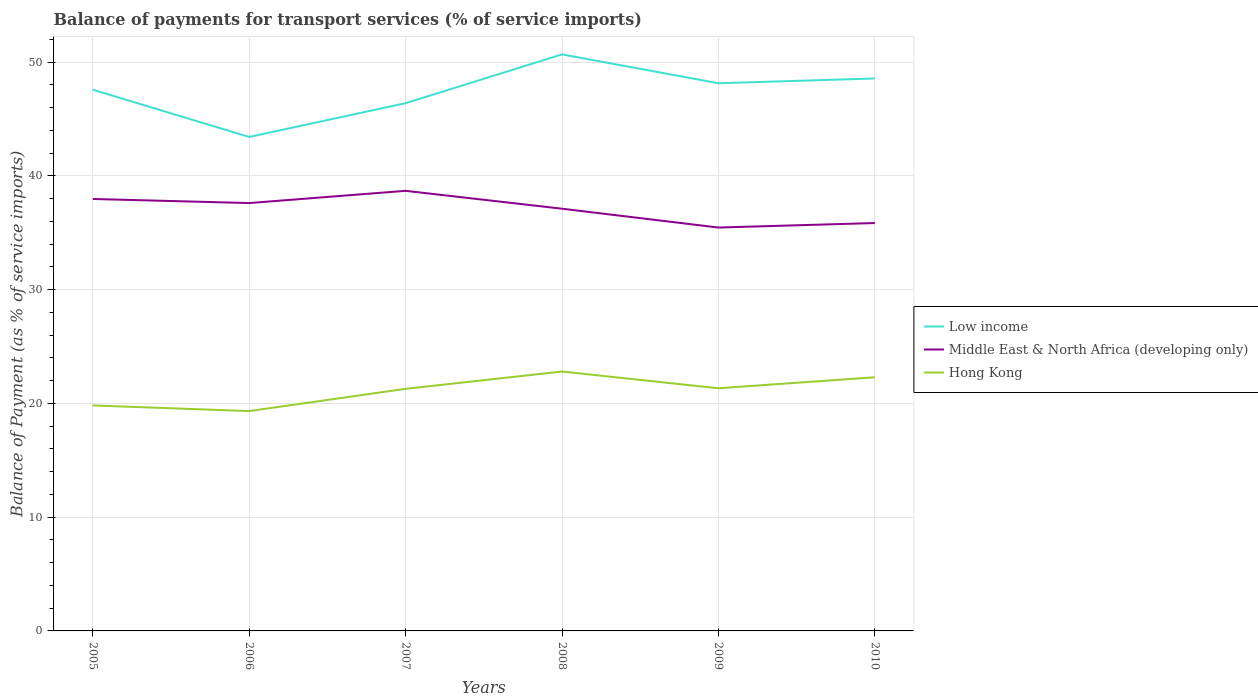How many different coloured lines are there?
Offer a very short reply. 3. Does the line corresponding to Middle East & North Africa (developing only) intersect with the line corresponding to Hong Kong?
Keep it short and to the point. No. Across all years, what is the maximum balance of payments for transport services in Low income?
Make the answer very short. 43.42. What is the total balance of payments for transport services in Hong Kong in the graph?
Offer a very short reply. -2.48. What is the difference between the highest and the second highest balance of payments for transport services in Middle East & North Africa (developing only)?
Offer a very short reply. 3.23. Is the balance of payments for transport services in Low income strictly greater than the balance of payments for transport services in Middle East & North Africa (developing only) over the years?
Your answer should be compact. No. How many lines are there?
Give a very brief answer. 3. Does the graph contain grids?
Offer a terse response. Yes. Where does the legend appear in the graph?
Offer a terse response. Center right. What is the title of the graph?
Your answer should be compact. Balance of payments for transport services (% of service imports). What is the label or title of the Y-axis?
Your answer should be compact. Balance of Payment (as % of service imports). What is the Balance of Payment (as % of service imports) in Low income in 2005?
Offer a very short reply. 47.58. What is the Balance of Payment (as % of service imports) of Middle East & North Africa (developing only) in 2005?
Ensure brevity in your answer.  37.97. What is the Balance of Payment (as % of service imports) in Hong Kong in 2005?
Ensure brevity in your answer.  19.82. What is the Balance of Payment (as % of service imports) of Low income in 2006?
Keep it short and to the point. 43.42. What is the Balance of Payment (as % of service imports) of Middle East & North Africa (developing only) in 2006?
Give a very brief answer. 37.61. What is the Balance of Payment (as % of service imports) in Hong Kong in 2006?
Provide a succinct answer. 19.32. What is the Balance of Payment (as % of service imports) of Low income in 2007?
Your response must be concise. 46.39. What is the Balance of Payment (as % of service imports) of Middle East & North Africa (developing only) in 2007?
Your answer should be compact. 38.69. What is the Balance of Payment (as % of service imports) in Hong Kong in 2007?
Your answer should be very brief. 21.28. What is the Balance of Payment (as % of service imports) of Low income in 2008?
Provide a succinct answer. 50.68. What is the Balance of Payment (as % of service imports) in Middle East & North Africa (developing only) in 2008?
Make the answer very short. 37.12. What is the Balance of Payment (as % of service imports) in Hong Kong in 2008?
Keep it short and to the point. 22.8. What is the Balance of Payment (as % of service imports) of Low income in 2009?
Ensure brevity in your answer.  48.14. What is the Balance of Payment (as % of service imports) of Middle East & North Africa (developing only) in 2009?
Provide a short and direct response. 35.46. What is the Balance of Payment (as % of service imports) of Hong Kong in 2009?
Offer a terse response. 21.33. What is the Balance of Payment (as % of service imports) in Low income in 2010?
Make the answer very short. 48.57. What is the Balance of Payment (as % of service imports) of Middle East & North Africa (developing only) in 2010?
Ensure brevity in your answer.  35.86. What is the Balance of Payment (as % of service imports) of Hong Kong in 2010?
Your answer should be compact. 22.3. Across all years, what is the maximum Balance of Payment (as % of service imports) of Low income?
Offer a terse response. 50.68. Across all years, what is the maximum Balance of Payment (as % of service imports) in Middle East & North Africa (developing only)?
Your answer should be compact. 38.69. Across all years, what is the maximum Balance of Payment (as % of service imports) of Hong Kong?
Ensure brevity in your answer.  22.8. Across all years, what is the minimum Balance of Payment (as % of service imports) in Low income?
Offer a very short reply. 43.42. Across all years, what is the minimum Balance of Payment (as % of service imports) of Middle East & North Africa (developing only)?
Offer a very short reply. 35.46. Across all years, what is the minimum Balance of Payment (as % of service imports) in Hong Kong?
Provide a succinct answer. 19.32. What is the total Balance of Payment (as % of service imports) of Low income in the graph?
Offer a terse response. 284.78. What is the total Balance of Payment (as % of service imports) in Middle East & North Africa (developing only) in the graph?
Provide a succinct answer. 222.7. What is the total Balance of Payment (as % of service imports) of Hong Kong in the graph?
Ensure brevity in your answer.  126.86. What is the difference between the Balance of Payment (as % of service imports) in Low income in 2005 and that in 2006?
Your answer should be compact. 4.15. What is the difference between the Balance of Payment (as % of service imports) of Middle East & North Africa (developing only) in 2005 and that in 2006?
Provide a short and direct response. 0.36. What is the difference between the Balance of Payment (as % of service imports) in Hong Kong in 2005 and that in 2006?
Your answer should be compact. 0.5. What is the difference between the Balance of Payment (as % of service imports) of Low income in 2005 and that in 2007?
Offer a very short reply. 1.18. What is the difference between the Balance of Payment (as % of service imports) of Middle East & North Africa (developing only) in 2005 and that in 2007?
Keep it short and to the point. -0.71. What is the difference between the Balance of Payment (as % of service imports) in Hong Kong in 2005 and that in 2007?
Give a very brief answer. -1.46. What is the difference between the Balance of Payment (as % of service imports) in Low income in 2005 and that in 2008?
Ensure brevity in your answer.  -3.1. What is the difference between the Balance of Payment (as % of service imports) in Middle East & North Africa (developing only) in 2005 and that in 2008?
Your answer should be very brief. 0.86. What is the difference between the Balance of Payment (as % of service imports) of Hong Kong in 2005 and that in 2008?
Ensure brevity in your answer.  -2.98. What is the difference between the Balance of Payment (as % of service imports) of Low income in 2005 and that in 2009?
Provide a succinct answer. -0.57. What is the difference between the Balance of Payment (as % of service imports) in Middle East & North Africa (developing only) in 2005 and that in 2009?
Keep it short and to the point. 2.51. What is the difference between the Balance of Payment (as % of service imports) of Hong Kong in 2005 and that in 2009?
Keep it short and to the point. -1.51. What is the difference between the Balance of Payment (as % of service imports) in Low income in 2005 and that in 2010?
Give a very brief answer. -0.99. What is the difference between the Balance of Payment (as % of service imports) of Middle East & North Africa (developing only) in 2005 and that in 2010?
Make the answer very short. 2.12. What is the difference between the Balance of Payment (as % of service imports) in Hong Kong in 2005 and that in 2010?
Your answer should be compact. -2.48. What is the difference between the Balance of Payment (as % of service imports) in Low income in 2006 and that in 2007?
Your response must be concise. -2.97. What is the difference between the Balance of Payment (as % of service imports) in Middle East & North Africa (developing only) in 2006 and that in 2007?
Provide a short and direct response. -1.08. What is the difference between the Balance of Payment (as % of service imports) of Hong Kong in 2006 and that in 2007?
Your answer should be very brief. -1.96. What is the difference between the Balance of Payment (as % of service imports) of Low income in 2006 and that in 2008?
Provide a succinct answer. -7.26. What is the difference between the Balance of Payment (as % of service imports) in Middle East & North Africa (developing only) in 2006 and that in 2008?
Provide a short and direct response. 0.5. What is the difference between the Balance of Payment (as % of service imports) of Hong Kong in 2006 and that in 2008?
Keep it short and to the point. -3.48. What is the difference between the Balance of Payment (as % of service imports) of Low income in 2006 and that in 2009?
Ensure brevity in your answer.  -4.72. What is the difference between the Balance of Payment (as % of service imports) in Middle East & North Africa (developing only) in 2006 and that in 2009?
Ensure brevity in your answer.  2.15. What is the difference between the Balance of Payment (as % of service imports) in Hong Kong in 2006 and that in 2009?
Provide a succinct answer. -2.01. What is the difference between the Balance of Payment (as % of service imports) of Low income in 2006 and that in 2010?
Provide a succinct answer. -5.14. What is the difference between the Balance of Payment (as % of service imports) of Middle East & North Africa (developing only) in 2006 and that in 2010?
Ensure brevity in your answer.  1.75. What is the difference between the Balance of Payment (as % of service imports) of Hong Kong in 2006 and that in 2010?
Provide a short and direct response. -2.97. What is the difference between the Balance of Payment (as % of service imports) in Low income in 2007 and that in 2008?
Provide a succinct answer. -4.29. What is the difference between the Balance of Payment (as % of service imports) in Middle East & North Africa (developing only) in 2007 and that in 2008?
Offer a very short reply. 1.57. What is the difference between the Balance of Payment (as % of service imports) of Hong Kong in 2007 and that in 2008?
Ensure brevity in your answer.  -1.52. What is the difference between the Balance of Payment (as % of service imports) of Low income in 2007 and that in 2009?
Provide a short and direct response. -1.75. What is the difference between the Balance of Payment (as % of service imports) of Middle East & North Africa (developing only) in 2007 and that in 2009?
Your response must be concise. 3.23. What is the difference between the Balance of Payment (as % of service imports) of Hong Kong in 2007 and that in 2009?
Make the answer very short. -0.05. What is the difference between the Balance of Payment (as % of service imports) in Low income in 2007 and that in 2010?
Your answer should be very brief. -2.17. What is the difference between the Balance of Payment (as % of service imports) in Middle East & North Africa (developing only) in 2007 and that in 2010?
Ensure brevity in your answer.  2.83. What is the difference between the Balance of Payment (as % of service imports) in Hong Kong in 2007 and that in 2010?
Your response must be concise. -1.02. What is the difference between the Balance of Payment (as % of service imports) in Low income in 2008 and that in 2009?
Your answer should be very brief. 2.54. What is the difference between the Balance of Payment (as % of service imports) of Middle East & North Africa (developing only) in 2008 and that in 2009?
Offer a very short reply. 1.66. What is the difference between the Balance of Payment (as % of service imports) of Hong Kong in 2008 and that in 2009?
Give a very brief answer. 1.47. What is the difference between the Balance of Payment (as % of service imports) in Low income in 2008 and that in 2010?
Offer a terse response. 2.11. What is the difference between the Balance of Payment (as % of service imports) in Middle East & North Africa (developing only) in 2008 and that in 2010?
Provide a succinct answer. 1.26. What is the difference between the Balance of Payment (as % of service imports) of Hong Kong in 2008 and that in 2010?
Your answer should be very brief. 0.51. What is the difference between the Balance of Payment (as % of service imports) of Low income in 2009 and that in 2010?
Your answer should be very brief. -0.42. What is the difference between the Balance of Payment (as % of service imports) of Middle East & North Africa (developing only) in 2009 and that in 2010?
Provide a short and direct response. -0.4. What is the difference between the Balance of Payment (as % of service imports) in Hong Kong in 2009 and that in 2010?
Your answer should be compact. -0.97. What is the difference between the Balance of Payment (as % of service imports) in Low income in 2005 and the Balance of Payment (as % of service imports) in Middle East & North Africa (developing only) in 2006?
Offer a terse response. 9.96. What is the difference between the Balance of Payment (as % of service imports) in Low income in 2005 and the Balance of Payment (as % of service imports) in Hong Kong in 2006?
Your response must be concise. 28.25. What is the difference between the Balance of Payment (as % of service imports) of Middle East & North Africa (developing only) in 2005 and the Balance of Payment (as % of service imports) of Hong Kong in 2006?
Keep it short and to the point. 18.65. What is the difference between the Balance of Payment (as % of service imports) of Low income in 2005 and the Balance of Payment (as % of service imports) of Middle East & North Africa (developing only) in 2007?
Make the answer very short. 8.89. What is the difference between the Balance of Payment (as % of service imports) of Low income in 2005 and the Balance of Payment (as % of service imports) of Hong Kong in 2007?
Provide a short and direct response. 26.29. What is the difference between the Balance of Payment (as % of service imports) in Middle East & North Africa (developing only) in 2005 and the Balance of Payment (as % of service imports) in Hong Kong in 2007?
Give a very brief answer. 16.69. What is the difference between the Balance of Payment (as % of service imports) in Low income in 2005 and the Balance of Payment (as % of service imports) in Middle East & North Africa (developing only) in 2008?
Your answer should be very brief. 10.46. What is the difference between the Balance of Payment (as % of service imports) in Low income in 2005 and the Balance of Payment (as % of service imports) in Hong Kong in 2008?
Provide a succinct answer. 24.77. What is the difference between the Balance of Payment (as % of service imports) in Middle East & North Africa (developing only) in 2005 and the Balance of Payment (as % of service imports) in Hong Kong in 2008?
Offer a very short reply. 15.17. What is the difference between the Balance of Payment (as % of service imports) in Low income in 2005 and the Balance of Payment (as % of service imports) in Middle East & North Africa (developing only) in 2009?
Offer a terse response. 12.12. What is the difference between the Balance of Payment (as % of service imports) of Low income in 2005 and the Balance of Payment (as % of service imports) of Hong Kong in 2009?
Offer a terse response. 26.25. What is the difference between the Balance of Payment (as % of service imports) of Middle East & North Africa (developing only) in 2005 and the Balance of Payment (as % of service imports) of Hong Kong in 2009?
Offer a very short reply. 16.64. What is the difference between the Balance of Payment (as % of service imports) of Low income in 2005 and the Balance of Payment (as % of service imports) of Middle East & North Africa (developing only) in 2010?
Offer a very short reply. 11.72. What is the difference between the Balance of Payment (as % of service imports) in Low income in 2005 and the Balance of Payment (as % of service imports) in Hong Kong in 2010?
Offer a terse response. 25.28. What is the difference between the Balance of Payment (as % of service imports) in Middle East & North Africa (developing only) in 2005 and the Balance of Payment (as % of service imports) in Hong Kong in 2010?
Keep it short and to the point. 15.67. What is the difference between the Balance of Payment (as % of service imports) in Low income in 2006 and the Balance of Payment (as % of service imports) in Middle East & North Africa (developing only) in 2007?
Provide a short and direct response. 4.74. What is the difference between the Balance of Payment (as % of service imports) of Low income in 2006 and the Balance of Payment (as % of service imports) of Hong Kong in 2007?
Ensure brevity in your answer.  22.14. What is the difference between the Balance of Payment (as % of service imports) of Middle East & North Africa (developing only) in 2006 and the Balance of Payment (as % of service imports) of Hong Kong in 2007?
Give a very brief answer. 16.33. What is the difference between the Balance of Payment (as % of service imports) in Low income in 2006 and the Balance of Payment (as % of service imports) in Middle East & North Africa (developing only) in 2008?
Provide a succinct answer. 6.31. What is the difference between the Balance of Payment (as % of service imports) in Low income in 2006 and the Balance of Payment (as % of service imports) in Hong Kong in 2008?
Your response must be concise. 20.62. What is the difference between the Balance of Payment (as % of service imports) of Middle East & North Africa (developing only) in 2006 and the Balance of Payment (as % of service imports) of Hong Kong in 2008?
Your answer should be compact. 14.81. What is the difference between the Balance of Payment (as % of service imports) of Low income in 2006 and the Balance of Payment (as % of service imports) of Middle East & North Africa (developing only) in 2009?
Keep it short and to the point. 7.96. What is the difference between the Balance of Payment (as % of service imports) of Low income in 2006 and the Balance of Payment (as % of service imports) of Hong Kong in 2009?
Your answer should be compact. 22.09. What is the difference between the Balance of Payment (as % of service imports) of Middle East & North Africa (developing only) in 2006 and the Balance of Payment (as % of service imports) of Hong Kong in 2009?
Provide a short and direct response. 16.28. What is the difference between the Balance of Payment (as % of service imports) in Low income in 2006 and the Balance of Payment (as % of service imports) in Middle East & North Africa (developing only) in 2010?
Make the answer very short. 7.57. What is the difference between the Balance of Payment (as % of service imports) in Low income in 2006 and the Balance of Payment (as % of service imports) in Hong Kong in 2010?
Provide a short and direct response. 21.12. What is the difference between the Balance of Payment (as % of service imports) in Middle East & North Africa (developing only) in 2006 and the Balance of Payment (as % of service imports) in Hong Kong in 2010?
Your answer should be compact. 15.31. What is the difference between the Balance of Payment (as % of service imports) in Low income in 2007 and the Balance of Payment (as % of service imports) in Middle East & North Africa (developing only) in 2008?
Offer a terse response. 9.28. What is the difference between the Balance of Payment (as % of service imports) in Low income in 2007 and the Balance of Payment (as % of service imports) in Hong Kong in 2008?
Ensure brevity in your answer.  23.59. What is the difference between the Balance of Payment (as % of service imports) of Middle East & North Africa (developing only) in 2007 and the Balance of Payment (as % of service imports) of Hong Kong in 2008?
Your response must be concise. 15.88. What is the difference between the Balance of Payment (as % of service imports) in Low income in 2007 and the Balance of Payment (as % of service imports) in Middle East & North Africa (developing only) in 2009?
Your answer should be very brief. 10.93. What is the difference between the Balance of Payment (as % of service imports) in Low income in 2007 and the Balance of Payment (as % of service imports) in Hong Kong in 2009?
Provide a succinct answer. 25.06. What is the difference between the Balance of Payment (as % of service imports) of Middle East & North Africa (developing only) in 2007 and the Balance of Payment (as % of service imports) of Hong Kong in 2009?
Your answer should be very brief. 17.36. What is the difference between the Balance of Payment (as % of service imports) of Low income in 2007 and the Balance of Payment (as % of service imports) of Middle East & North Africa (developing only) in 2010?
Offer a very short reply. 10.54. What is the difference between the Balance of Payment (as % of service imports) of Low income in 2007 and the Balance of Payment (as % of service imports) of Hong Kong in 2010?
Ensure brevity in your answer.  24.1. What is the difference between the Balance of Payment (as % of service imports) of Middle East & North Africa (developing only) in 2007 and the Balance of Payment (as % of service imports) of Hong Kong in 2010?
Ensure brevity in your answer.  16.39. What is the difference between the Balance of Payment (as % of service imports) of Low income in 2008 and the Balance of Payment (as % of service imports) of Middle East & North Africa (developing only) in 2009?
Your answer should be compact. 15.22. What is the difference between the Balance of Payment (as % of service imports) in Low income in 2008 and the Balance of Payment (as % of service imports) in Hong Kong in 2009?
Make the answer very short. 29.35. What is the difference between the Balance of Payment (as % of service imports) of Middle East & North Africa (developing only) in 2008 and the Balance of Payment (as % of service imports) of Hong Kong in 2009?
Offer a very short reply. 15.78. What is the difference between the Balance of Payment (as % of service imports) of Low income in 2008 and the Balance of Payment (as % of service imports) of Middle East & North Africa (developing only) in 2010?
Your answer should be compact. 14.82. What is the difference between the Balance of Payment (as % of service imports) of Low income in 2008 and the Balance of Payment (as % of service imports) of Hong Kong in 2010?
Ensure brevity in your answer.  28.38. What is the difference between the Balance of Payment (as % of service imports) in Middle East & North Africa (developing only) in 2008 and the Balance of Payment (as % of service imports) in Hong Kong in 2010?
Make the answer very short. 14.82. What is the difference between the Balance of Payment (as % of service imports) of Low income in 2009 and the Balance of Payment (as % of service imports) of Middle East & North Africa (developing only) in 2010?
Keep it short and to the point. 12.29. What is the difference between the Balance of Payment (as % of service imports) in Low income in 2009 and the Balance of Payment (as % of service imports) in Hong Kong in 2010?
Provide a succinct answer. 25.85. What is the difference between the Balance of Payment (as % of service imports) in Middle East & North Africa (developing only) in 2009 and the Balance of Payment (as % of service imports) in Hong Kong in 2010?
Keep it short and to the point. 13.16. What is the average Balance of Payment (as % of service imports) of Low income per year?
Your answer should be compact. 47.46. What is the average Balance of Payment (as % of service imports) in Middle East & North Africa (developing only) per year?
Your answer should be compact. 37.12. What is the average Balance of Payment (as % of service imports) of Hong Kong per year?
Keep it short and to the point. 21.14. In the year 2005, what is the difference between the Balance of Payment (as % of service imports) in Low income and Balance of Payment (as % of service imports) in Middle East & North Africa (developing only)?
Provide a succinct answer. 9.6. In the year 2005, what is the difference between the Balance of Payment (as % of service imports) of Low income and Balance of Payment (as % of service imports) of Hong Kong?
Keep it short and to the point. 27.75. In the year 2005, what is the difference between the Balance of Payment (as % of service imports) in Middle East & North Africa (developing only) and Balance of Payment (as % of service imports) in Hong Kong?
Offer a very short reply. 18.15. In the year 2006, what is the difference between the Balance of Payment (as % of service imports) of Low income and Balance of Payment (as % of service imports) of Middle East & North Africa (developing only)?
Provide a short and direct response. 5.81. In the year 2006, what is the difference between the Balance of Payment (as % of service imports) of Low income and Balance of Payment (as % of service imports) of Hong Kong?
Give a very brief answer. 24.1. In the year 2006, what is the difference between the Balance of Payment (as % of service imports) in Middle East & North Africa (developing only) and Balance of Payment (as % of service imports) in Hong Kong?
Ensure brevity in your answer.  18.29. In the year 2007, what is the difference between the Balance of Payment (as % of service imports) of Low income and Balance of Payment (as % of service imports) of Middle East & North Africa (developing only)?
Provide a succinct answer. 7.71. In the year 2007, what is the difference between the Balance of Payment (as % of service imports) in Low income and Balance of Payment (as % of service imports) in Hong Kong?
Provide a succinct answer. 25.11. In the year 2007, what is the difference between the Balance of Payment (as % of service imports) in Middle East & North Africa (developing only) and Balance of Payment (as % of service imports) in Hong Kong?
Your answer should be compact. 17.4. In the year 2008, what is the difference between the Balance of Payment (as % of service imports) in Low income and Balance of Payment (as % of service imports) in Middle East & North Africa (developing only)?
Give a very brief answer. 13.56. In the year 2008, what is the difference between the Balance of Payment (as % of service imports) of Low income and Balance of Payment (as % of service imports) of Hong Kong?
Provide a succinct answer. 27.88. In the year 2008, what is the difference between the Balance of Payment (as % of service imports) in Middle East & North Africa (developing only) and Balance of Payment (as % of service imports) in Hong Kong?
Ensure brevity in your answer.  14.31. In the year 2009, what is the difference between the Balance of Payment (as % of service imports) in Low income and Balance of Payment (as % of service imports) in Middle East & North Africa (developing only)?
Make the answer very short. 12.68. In the year 2009, what is the difference between the Balance of Payment (as % of service imports) in Low income and Balance of Payment (as % of service imports) in Hong Kong?
Make the answer very short. 26.81. In the year 2009, what is the difference between the Balance of Payment (as % of service imports) in Middle East & North Africa (developing only) and Balance of Payment (as % of service imports) in Hong Kong?
Your answer should be compact. 14.13. In the year 2010, what is the difference between the Balance of Payment (as % of service imports) in Low income and Balance of Payment (as % of service imports) in Middle East & North Africa (developing only)?
Make the answer very short. 12.71. In the year 2010, what is the difference between the Balance of Payment (as % of service imports) in Low income and Balance of Payment (as % of service imports) in Hong Kong?
Your answer should be compact. 26.27. In the year 2010, what is the difference between the Balance of Payment (as % of service imports) in Middle East & North Africa (developing only) and Balance of Payment (as % of service imports) in Hong Kong?
Provide a short and direct response. 13.56. What is the ratio of the Balance of Payment (as % of service imports) in Low income in 2005 to that in 2006?
Offer a terse response. 1.1. What is the ratio of the Balance of Payment (as % of service imports) of Middle East & North Africa (developing only) in 2005 to that in 2006?
Offer a terse response. 1.01. What is the ratio of the Balance of Payment (as % of service imports) in Hong Kong in 2005 to that in 2006?
Provide a succinct answer. 1.03. What is the ratio of the Balance of Payment (as % of service imports) in Low income in 2005 to that in 2007?
Your answer should be compact. 1.03. What is the ratio of the Balance of Payment (as % of service imports) of Middle East & North Africa (developing only) in 2005 to that in 2007?
Your answer should be compact. 0.98. What is the ratio of the Balance of Payment (as % of service imports) of Hong Kong in 2005 to that in 2007?
Give a very brief answer. 0.93. What is the ratio of the Balance of Payment (as % of service imports) in Low income in 2005 to that in 2008?
Your answer should be very brief. 0.94. What is the ratio of the Balance of Payment (as % of service imports) in Middle East & North Africa (developing only) in 2005 to that in 2008?
Your response must be concise. 1.02. What is the ratio of the Balance of Payment (as % of service imports) in Hong Kong in 2005 to that in 2008?
Provide a succinct answer. 0.87. What is the ratio of the Balance of Payment (as % of service imports) in Middle East & North Africa (developing only) in 2005 to that in 2009?
Keep it short and to the point. 1.07. What is the ratio of the Balance of Payment (as % of service imports) of Hong Kong in 2005 to that in 2009?
Give a very brief answer. 0.93. What is the ratio of the Balance of Payment (as % of service imports) of Low income in 2005 to that in 2010?
Ensure brevity in your answer.  0.98. What is the ratio of the Balance of Payment (as % of service imports) in Middle East & North Africa (developing only) in 2005 to that in 2010?
Provide a short and direct response. 1.06. What is the ratio of the Balance of Payment (as % of service imports) of Hong Kong in 2005 to that in 2010?
Make the answer very short. 0.89. What is the ratio of the Balance of Payment (as % of service imports) of Low income in 2006 to that in 2007?
Offer a terse response. 0.94. What is the ratio of the Balance of Payment (as % of service imports) in Middle East & North Africa (developing only) in 2006 to that in 2007?
Provide a succinct answer. 0.97. What is the ratio of the Balance of Payment (as % of service imports) in Hong Kong in 2006 to that in 2007?
Provide a short and direct response. 0.91. What is the ratio of the Balance of Payment (as % of service imports) of Low income in 2006 to that in 2008?
Give a very brief answer. 0.86. What is the ratio of the Balance of Payment (as % of service imports) of Middle East & North Africa (developing only) in 2006 to that in 2008?
Your answer should be compact. 1.01. What is the ratio of the Balance of Payment (as % of service imports) in Hong Kong in 2006 to that in 2008?
Your response must be concise. 0.85. What is the ratio of the Balance of Payment (as % of service imports) of Low income in 2006 to that in 2009?
Provide a succinct answer. 0.9. What is the ratio of the Balance of Payment (as % of service imports) in Middle East & North Africa (developing only) in 2006 to that in 2009?
Keep it short and to the point. 1.06. What is the ratio of the Balance of Payment (as % of service imports) in Hong Kong in 2006 to that in 2009?
Provide a short and direct response. 0.91. What is the ratio of the Balance of Payment (as % of service imports) in Low income in 2006 to that in 2010?
Offer a very short reply. 0.89. What is the ratio of the Balance of Payment (as % of service imports) of Middle East & North Africa (developing only) in 2006 to that in 2010?
Make the answer very short. 1.05. What is the ratio of the Balance of Payment (as % of service imports) in Hong Kong in 2006 to that in 2010?
Provide a succinct answer. 0.87. What is the ratio of the Balance of Payment (as % of service imports) of Low income in 2007 to that in 2008?
Provide a succinct answer. 0.92. What is the ratio of the Balance of Payment (as % of service imports) of Middle East & North Africa (developing only) in 2007 to that in 2008?
Provide a short and direct response. 1.04. What is the ratio of the Balance of Payment (as % of service imports) in Low income in 2007 to that in 2009?
Your response must be concise. 0.96. What is the ratio of the Balance of Payment (as % of service imports) of Middle East & North Africa (developing only) in 2007 to that in 2009?
Your answer should be compact. 1.09. What is the ratio of the Balance of Payment (as % of service imports) in Hong Kong in 2007 to that in 2009?
Give a very brief answer. 1. What is the ratio of the Balance of Payment (as % of service imports) of Low income in 2007 to that in 2010?
Ensure brevity in your answer.  0.96. What is the ratio of the Balance of Payment (as % of service imports) in Middle East & North Africa (developing only) in 2007 to that in 2010?
Offer a very short reply. 1.08. What is the ratio of the Balance of Payment (as % of service imports) of Hong Kong in 2007 to that in 2010?
Provide a short and direct response. 0.95. What is the ratio of the Balance of Payment (as % of service imports) in Low income in 2008 to that in 2009?
Provide a short and direct response. 1.05. What is the ratio of the Balance of Payment (as % of service imports) of Middle East & North Africa (developing only) in 2008 to that in 2009?
Offer a terse response. 1.05. What is the ratio of the Balance of Payment (as % of service imports) of Hong Kong in 2008 to that in 2009?
Your answer should be compact. 1.07. What is the ratio of the Balance of Payment (as % of service imports) of Low income in 2008 to that in 2010?
Your response must be concise. 1.04. What is the ratio of the Balance of Payment (as % of service imports) in Middle East & North Africa (developing only) in 2008 to that in 2010?
Keep it short and to the point. 1.04. What is the ratio of the Balance of Payment (as % of service imports) of Hong Kong in 2008 to that in 2010?
Your answer should be very brief. 1.02. What is the ratio of the Balance of Payment (as % of service imports) in Low income in 2009 to that in 2010?
Provide a succinct answer. 0.99. What is the ratio of the Balance of Payment (as % of service imports) in Middle East & North Africa (developing only) in 2009 to that in 2010?
Make the answer very short. 0.99. What is the ratio of the Balance of Payment (as % of service imports) in Hong Kong in 2009 to that in 2010?
Provide a short and direct response. 0.96. What is the difference between the highest and the second highest Balance of Payment (as % of service imports) of Low income?
Offer a very short reply. 2.11. What is the difference between the highest and the second highest Balance of Payment (as % of service imports) in Middle East & North Africa (developing only)?
Give a very brief answer. 0.71. What is the difference between the highest and the second highest Balance of Payment (as % of service imports) in Hong Kong?
Keep it short and to the point. 0.51. What is the difference between the highest and the lowest Balance of Payment (as % of service imports) in Low income?
Provide a succinct answer. 7.26. What is the difference between the highest and the lowest Balance of Payment (as % of service imports) in Middle East & North Africa (developing only)?
Provide a succinct answer. 3.23. What is the difference between the highest and the lowest Balance of Payment (as % of service imports) of Hong Kong?
Ensure brevity in your answer.  3.48. 